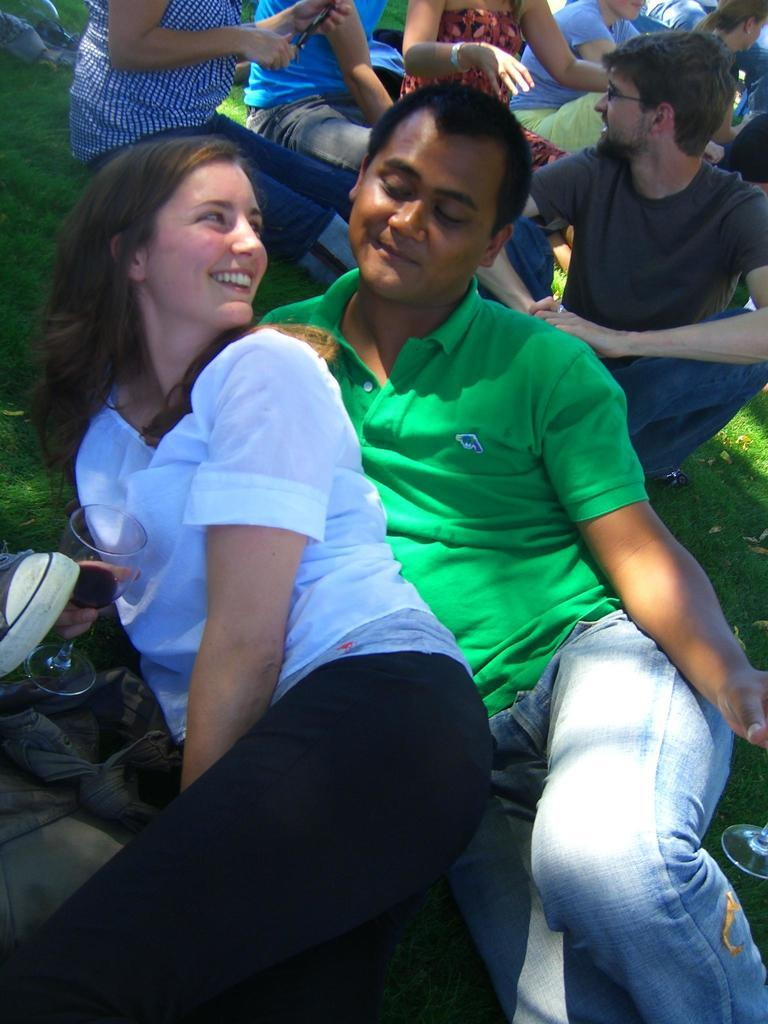What are the people in the image doing? There are people sitting and lying down in the image. Are any of the people holding anything? Yes, some people are holding objects in the image. What can be seen on the ground in the image? The ground is visible in the image, and grass is present on it. How many stars can be seen in the image? There are no stars visible in the image. What type of insurance is being discussed by the people in the image? There is no discussion about insurance in the image. 